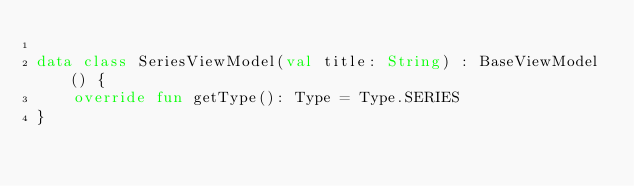Convert code to text. <code><loc_0><loc_0><loc_500><loc_500><_Kotlin_>
data class SeriesViewModel(val title: String) : BaseViewModel() {
    override fun getType(): Type = Type.SERIES
}</code> 